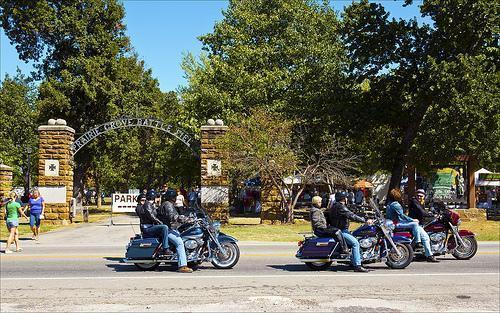How many red motorcycles are there?
Give a very brief answer. 1. 